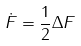Convert formula to latex. <formula><loc_0><loc_0><loc_500><loc_500>\dot { F } = \frac { 1 } { 2 } \Delta F</formula> 